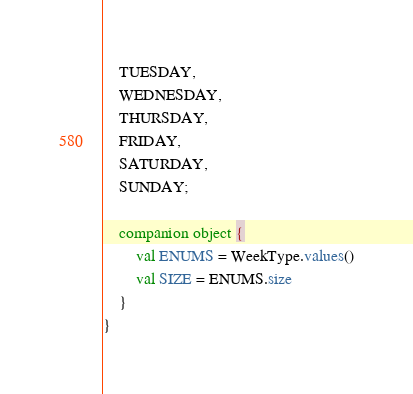<code> <loc_0><loc_0><loc_500><loc_500><_Kotlin_>    TUESDAY,
    WEDNESDAY,
    THURSDAY,
    FRIDAY,
    SATURDAY,
    SUNDAY;

    companion object {
        val ENUMS = WeekType.values()
        val SIZE = ENUMS.size
    }
}</code> 